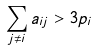<formula> <loc_0><loc_0><loc_500><loc_500>\sum _ { j \neq i } a _ { i j } > 3 p _ { i }</formula> 